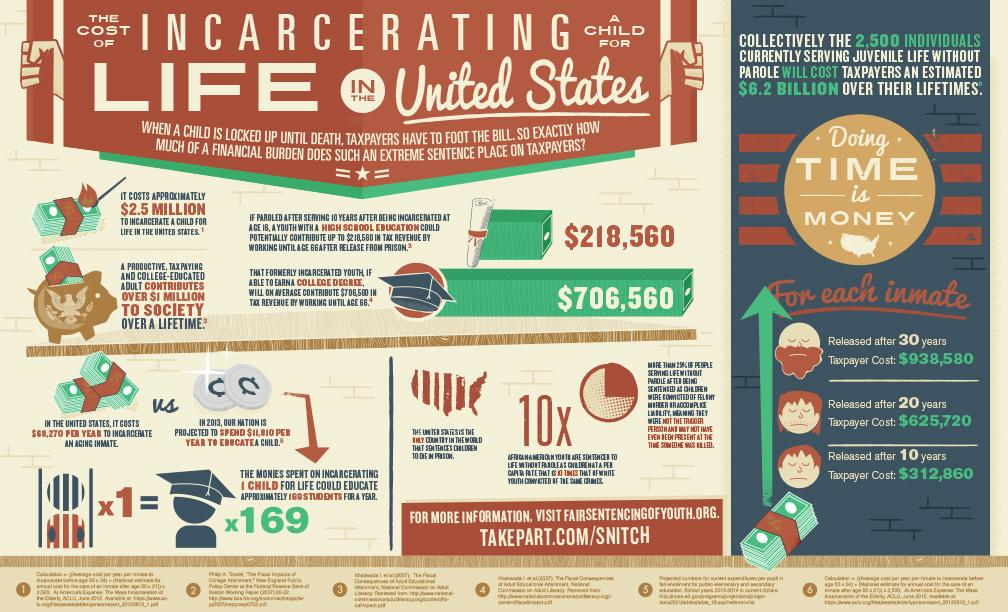Specify some key components in this picture. The total amount that taxpayers will need to pay to the 2,500 individuals is approximately $6.2 billion. I declare that educating 169 students for a year is equal to the monies spent on incarcerating 1 child. The estimated tax revenue for an incarcerated youth with a college degree is $706,560. According to projections in 2013, the estimated cost of education for each child was $11,810. The lifetime contribution of a college-educated tax-paying adult is estimated to be approximately $1 million. 